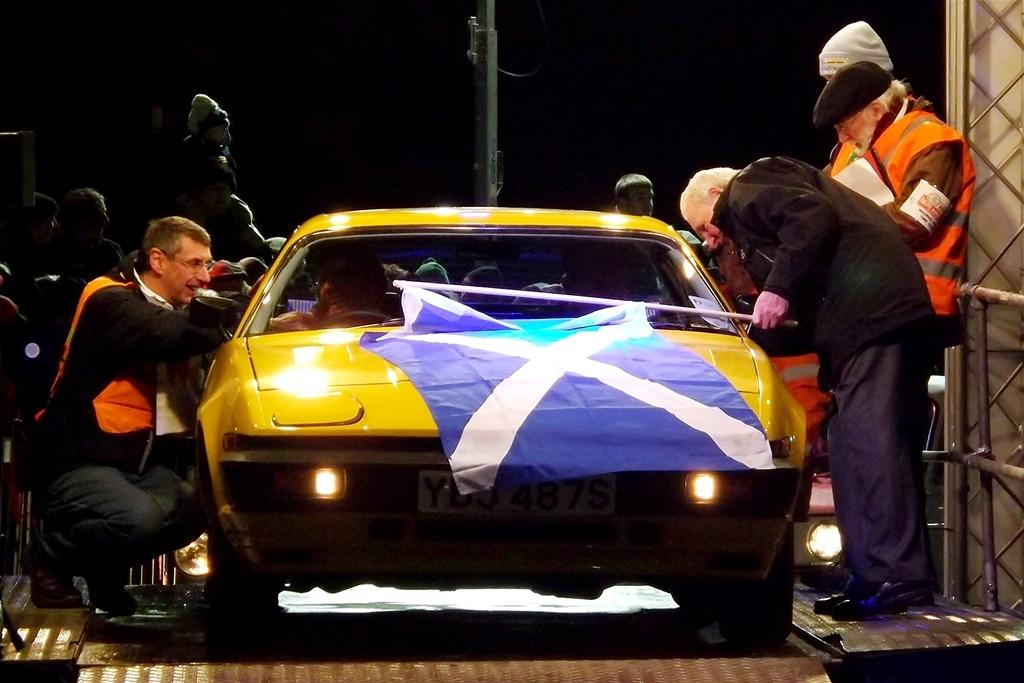What color is the vehicle in the image? The vehicle in the image is yellow. What are the people in the image doing? There are people standing in the image. What is the person in front of the vehicle holding? A person is holding a flag in front of the vehicle. What can be observed about the lighting in the image? The background of the image is dark. What type of meal is being prepared by the person in the image? There is no indication of a meal being prepared in the image; the focus is on the yellow vehicle and the people standing nearby. 